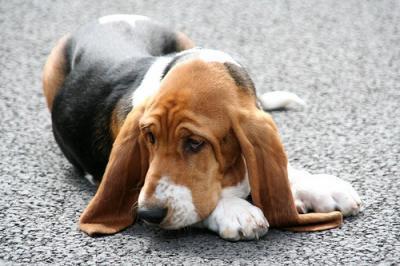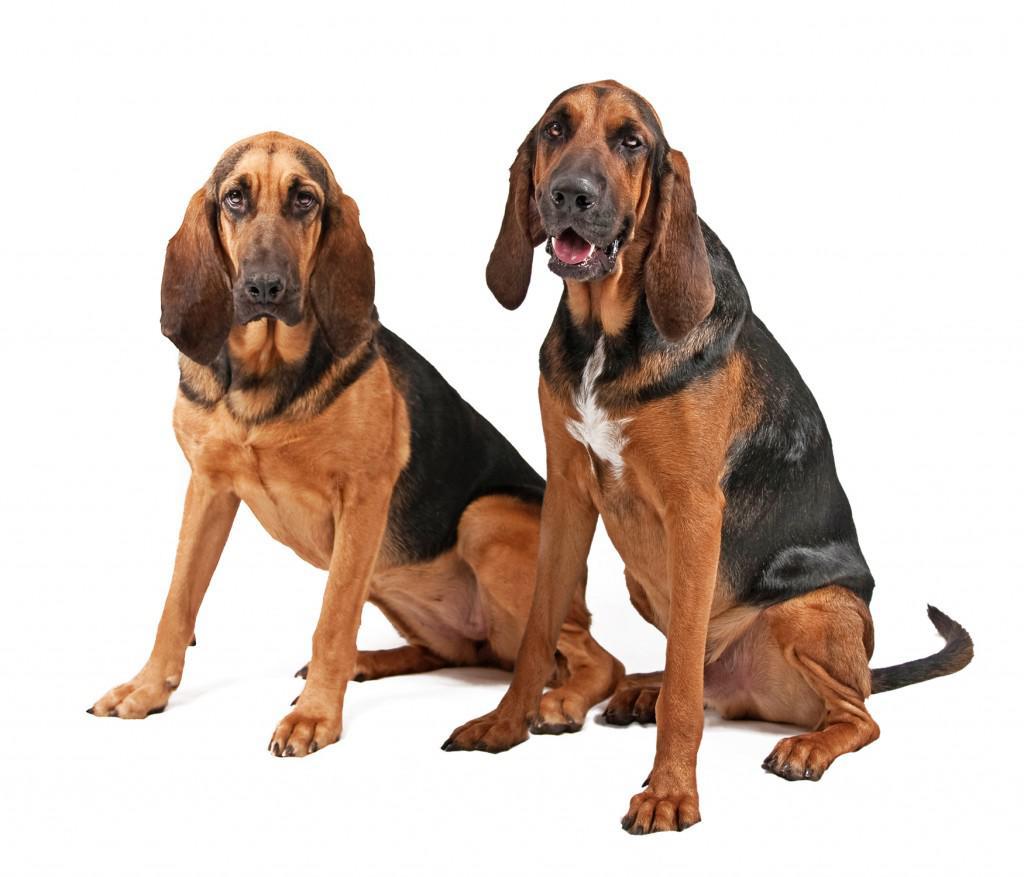The first image is the image on the left, the second image is the image on the right. For the images displayed, is the sentence "There are two dogs in total." factually correct? Answer yes or no. No. 